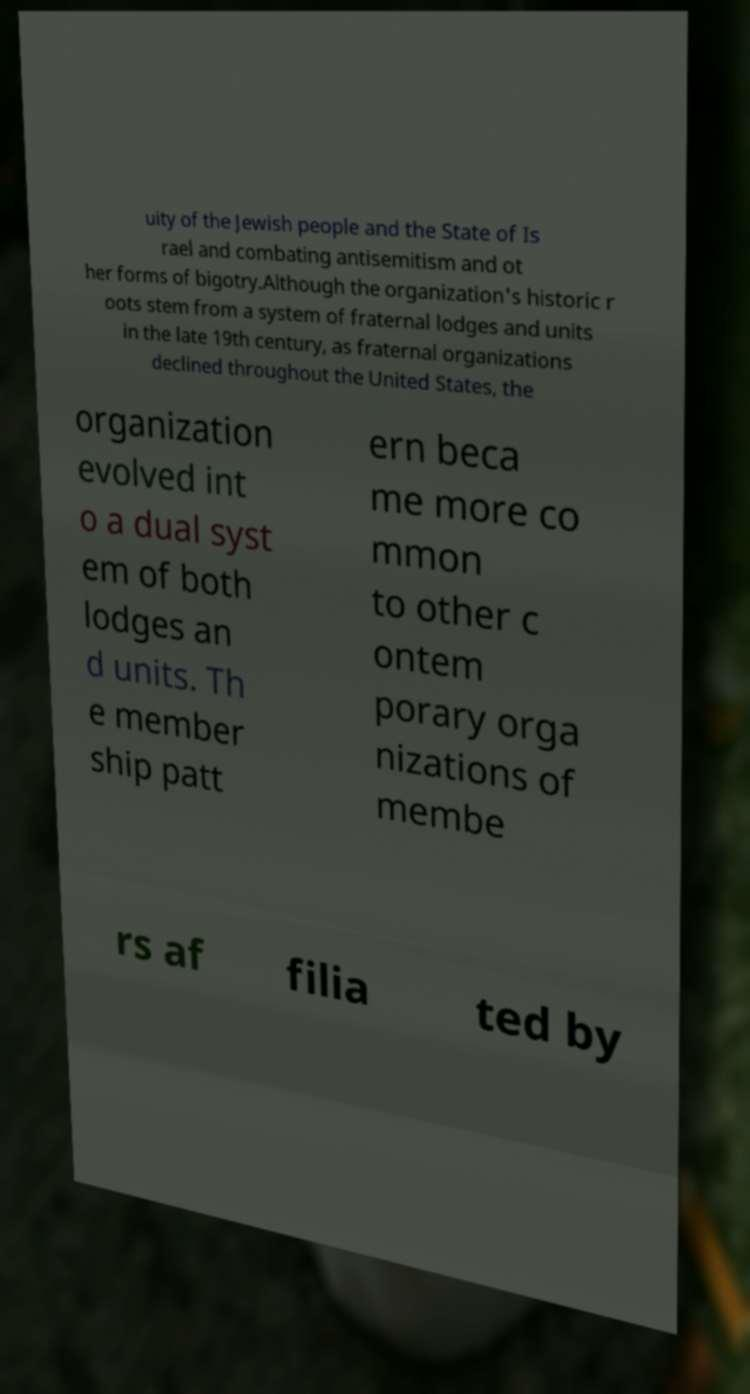Could you assist in decoding the text presented in this image and type it out clearly? uity of the Jewish people and the State of Is rael and combating antisemitism and ot her forms of bigotry.Although the organization's historic r oots stem from a system of fraternal lodges and units in the late 19th century, as fraternal organizations declined throughout the United States, the organization evolved int o a dual syst em of both lodges an d units. Th e member ship patt ern beca me more co mmon to other c ontem porary orga nizations of membe rs af filia ted by 